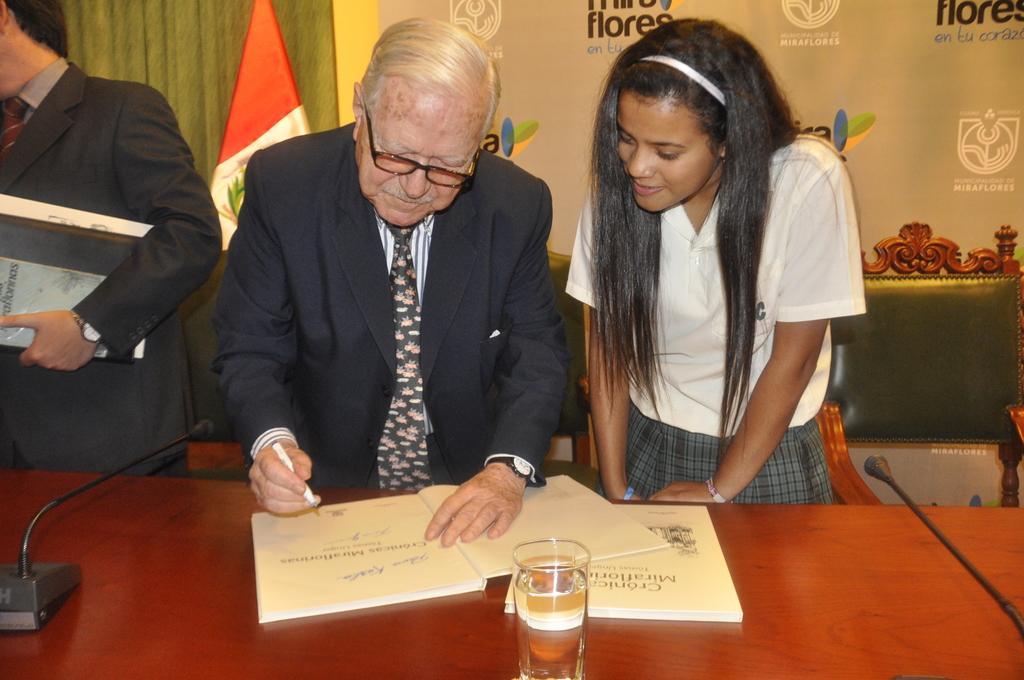Can you describe this image briefly? This picture is clicked inside. On the right there is a woman wearing white color t-shirt and standing. In the center there is a man wearing suit, holding a pen and writing something in the book and standing on the ground. On the left there is a person wearing suit and holding some books and standing. In the foreground we can see a table on the top of which we can see a glass of water, books and microphones are placed. In the background there is a banner on which we can see the text is printed and we can see the green color chairs and a flag. 